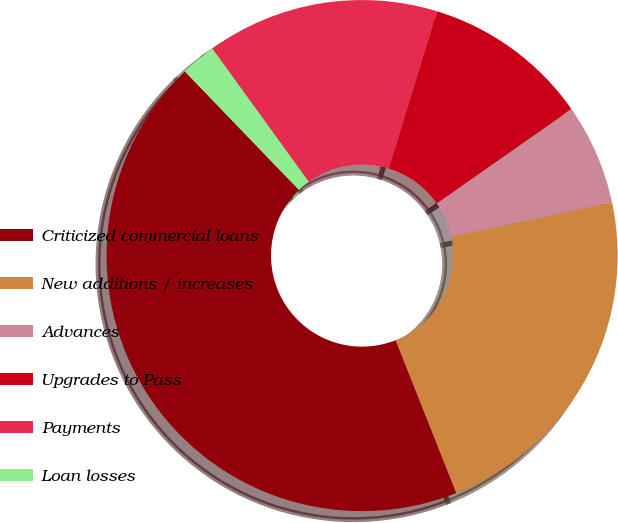<chart> <loc_0><loc_0><loc_500><loc_500><pie_chart><fcel>Criticized commercial loans<fcel>New additions / increases<fcel>Advances<fcel>Upgrades to Pass<fcel>Payments<fcel>Loan losses<nl><fcel>43.81%<fcel>22.33%<fcel>6.38%<fcel>10.54%<fcel>14.7%<fcel>2.23%<nl></chart> 